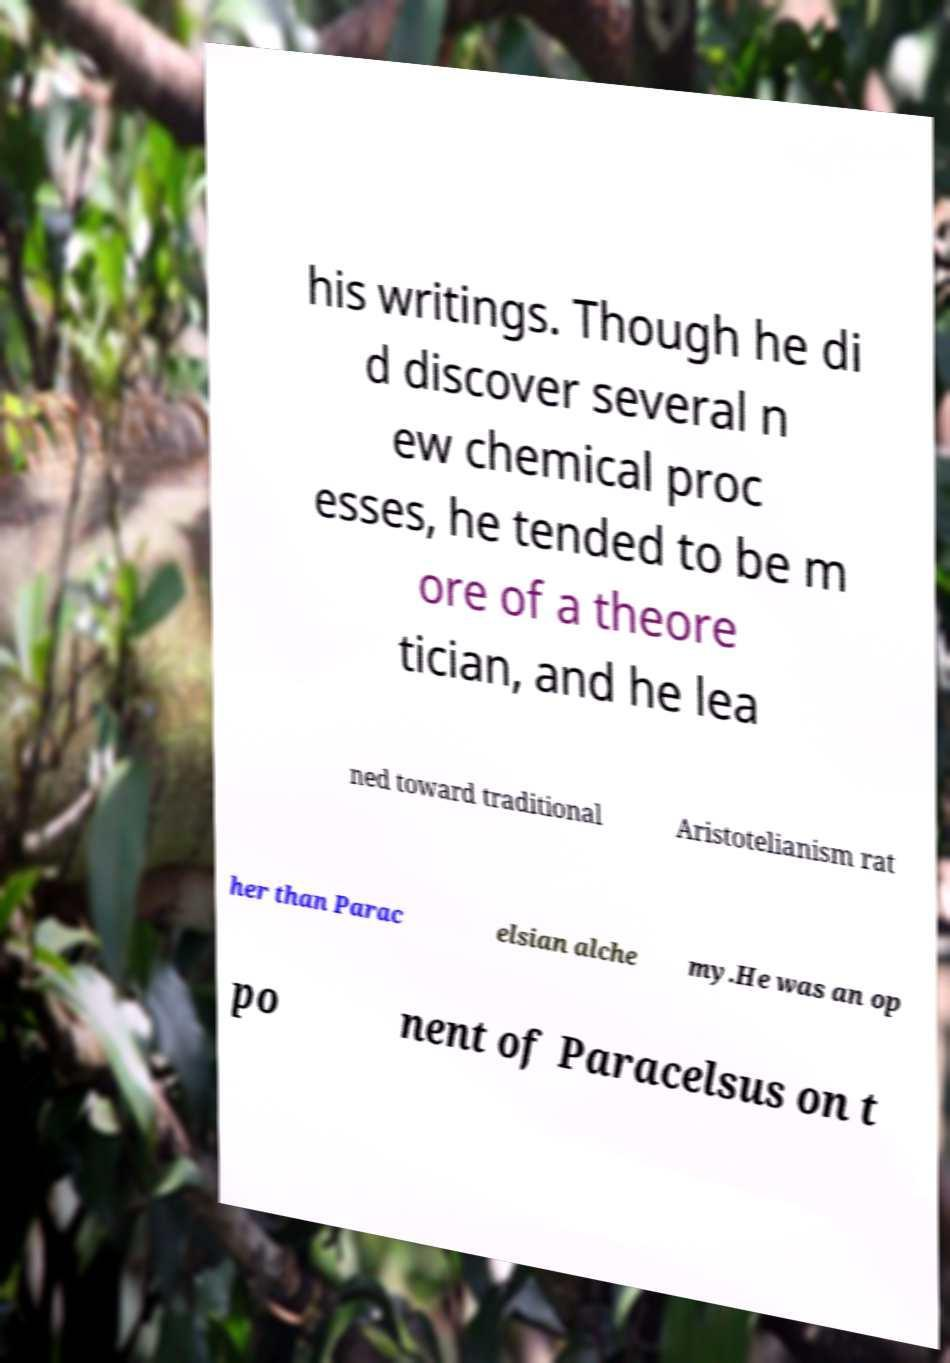What messages or text are displayed in this image? I need them in a readable, typed format. his writings. Though he di d discover several n ew chemical proc esses, he tended to be m ore of a theore tician, and he lea ned toward traditional Aristotelianism rat her than Parac elsian alche my.He was an op po nent of Paracelsus on t 